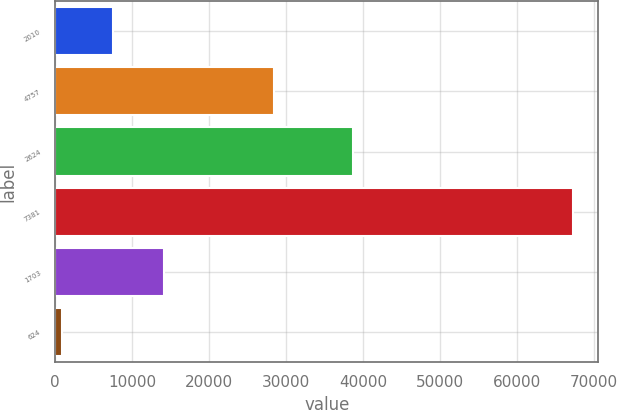<chart> <loc_0><loc_0><loc_500><loc_500><bar_chart><fcel>2010<fcel>4757<fcel>2624<fcel>7381<fcel>1703<fcel>624<nl><fcel>7558.6<fcel>28473<fcel>38779<fcel>67252<fcel>14191.2<fcel>926<nl></chart> 